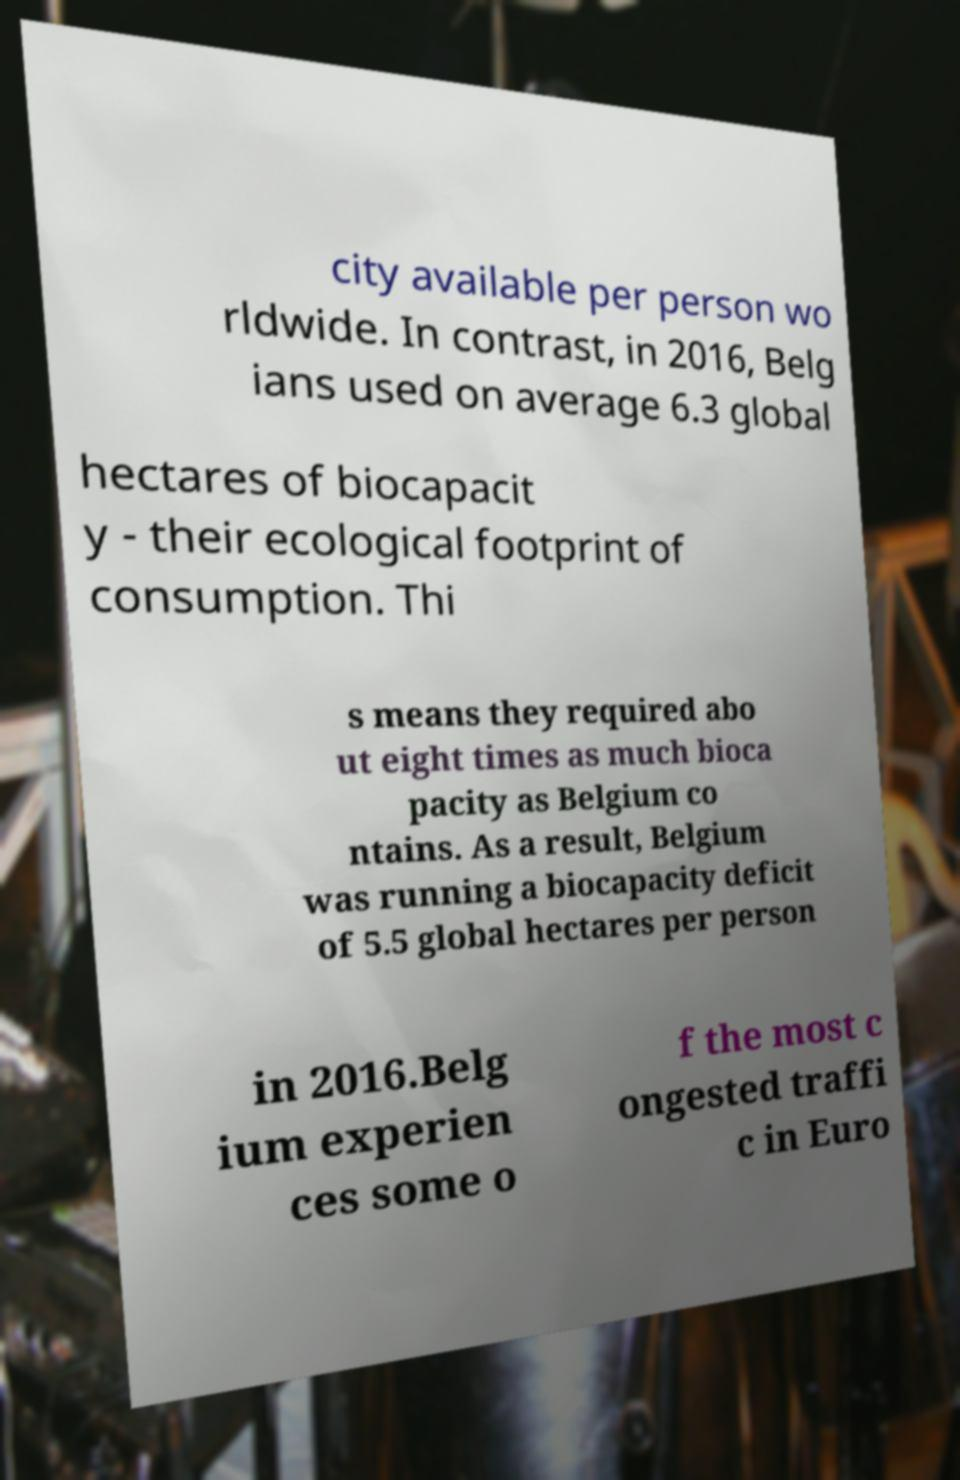For documentation purposes, I need the text within this image transcribed. Could you provide that? city available per person wo rldwide. In contrast, in 2016, Belg ians used on average 6.3 global hectares of biocapacit y - their ecological footprint of consumption. Thi s means they required abo ut eight times as much bioca pacity as Belgium co ntains. As a result, Belgium was running a biocapacity deficit of 5.5 global hectares per person in 2016.Belg ium experien ces some o f the most c ongested traffi c in Euro 